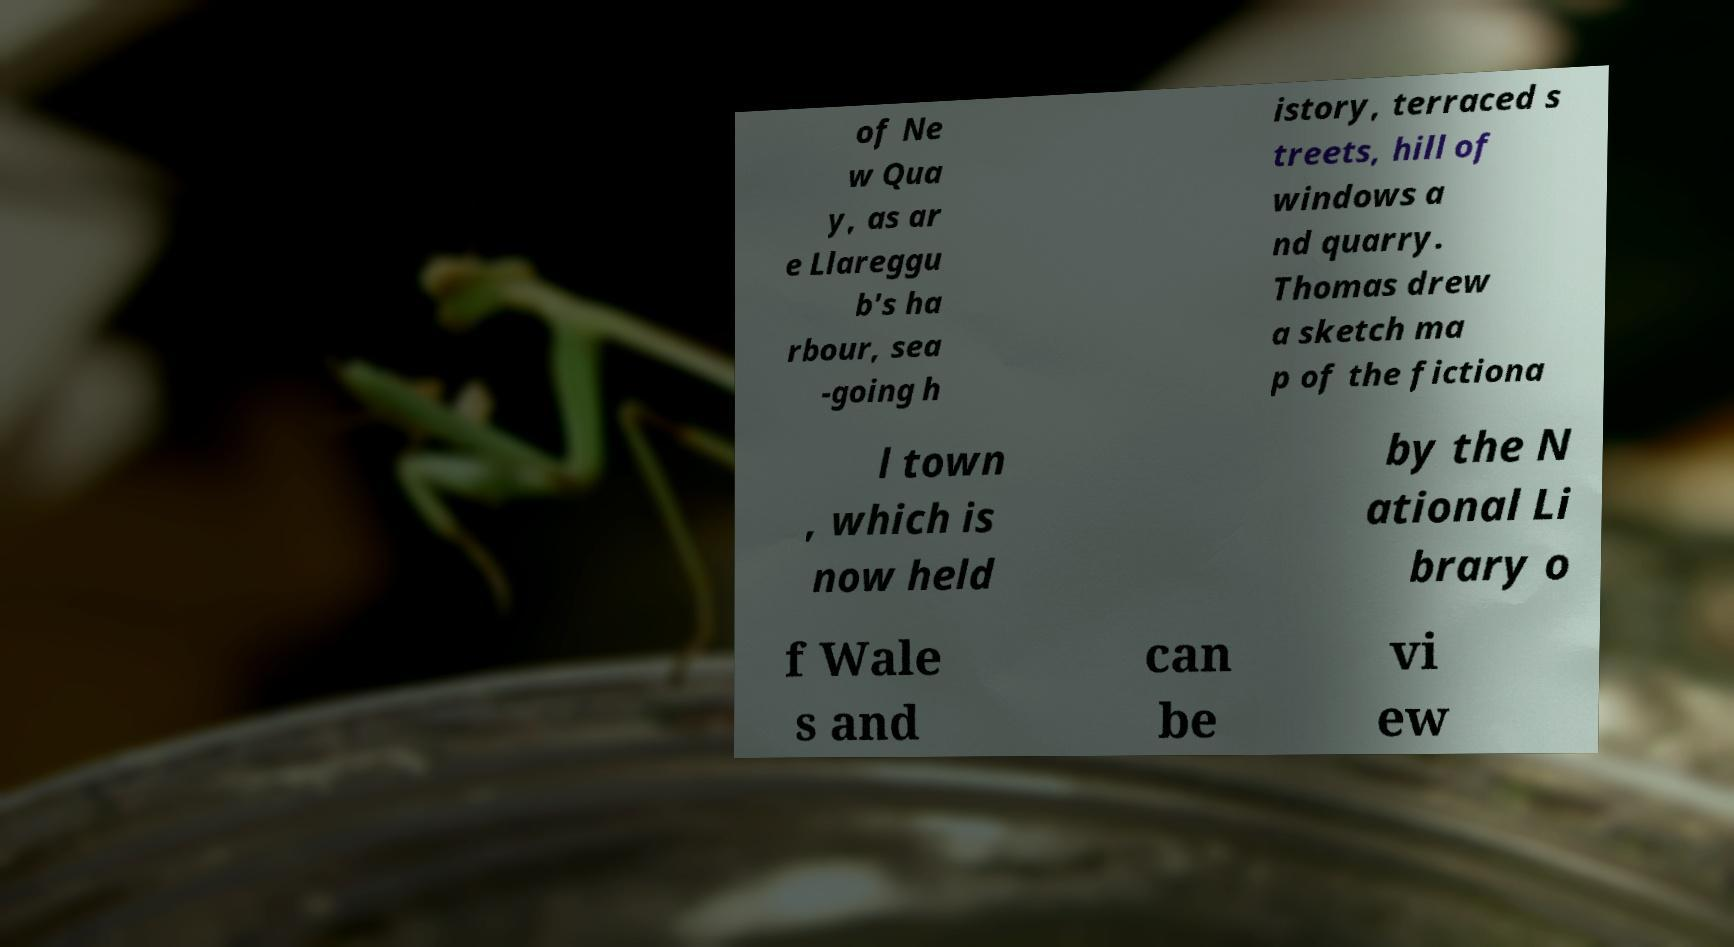Please identify and transcribe the text found in this image. of Ne w Qua y, as ar e Llareggu b's ha rbour, sea -going h istory, terraced s treets, hill of windows a nd quarry. Thomas drew a sketch ma p of the fictiona l town , which is now held by the N ational Li brary o f Wale s and can be vi ew 